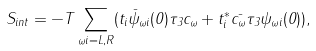<formula> <loc_0><loc_0><loc_500><loc_500>S _ { i n t } = - T \sum _ { \omega i = L , R } ( t _ { i } \bar { \psi } _ { \omega i } ( 0 ) \tau _ { 3 } c _ { \omega } + t ^ { * } _ { i } \bar { c _ { \omega } } \tau _ { 3 } \psi _ { \omega i } ( 0 ) ) ,</formula> 